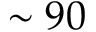<formula> <loc_0><loc_0><loc_500><loc_500>\sim 9 0</formula> 